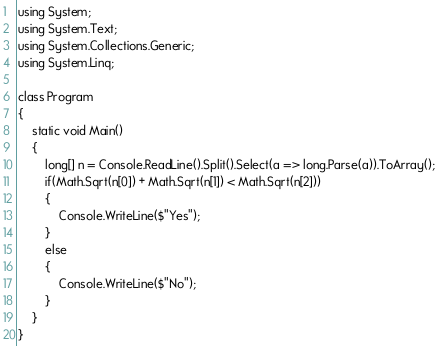Convert code to text. <code><loc_0><loc_0><loc_500><loc_500><_C#_>using System;
using System.Text;
using System.Collections.Generic;
using System.Linq;

class Program
{
    static void Main()
    {
        long[] n = Console.ReadLine().Split().Select(a => long.Parse(a)).ToArray();
        if(Math.Sqrt(n[0]) + Math.Sqrt(n[1]) < Math.Sqrt(n[2]))
        {
            Console.WriteLine($"Yes");
        }
        else
        {
            Console.WriteLine($"No");
        }
    }
}</code> 